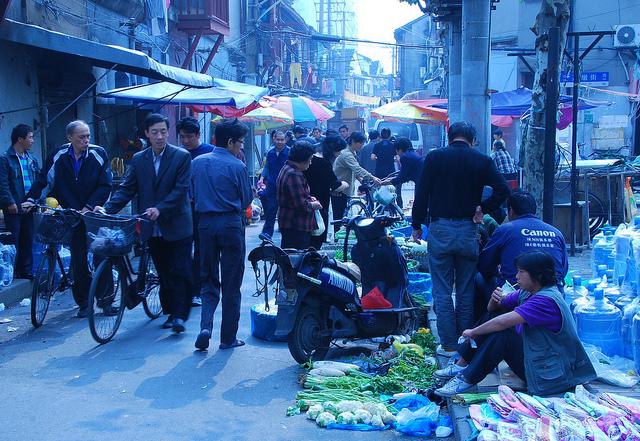Is this an outdoor market?
Short answer required. Yes. What is lying on the floor in front of the sitting woman?
Quick response, please. Vegetables. How many bicycles are visible in this picture?
Give a very brief answer. 3. 